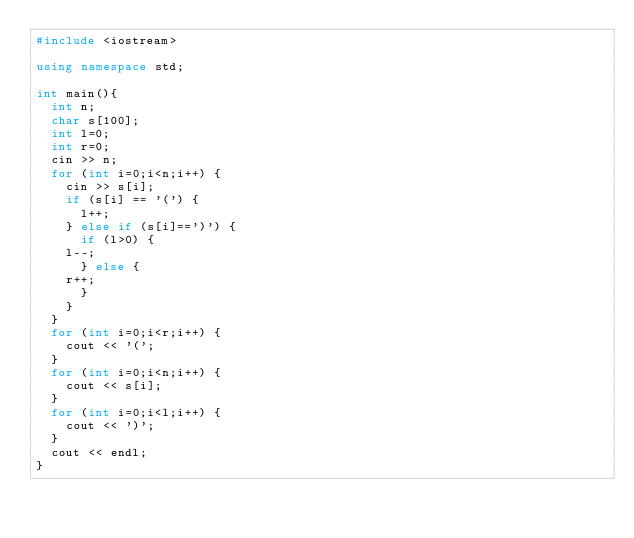<code> <loc_0><loc_0><loc_500><loc_500><_C++_>#include <iostream>

using namespace std;

int main(){
  int n;
  char s[100];
  int l=0;
  int r=0;
  cin >> n;
  for (int i=0;i<n;i++) {
    cin >> s[i];
    if (s[i] == '(') {
      l++;
    } else if (s[i]==')') {
      if (l>0) {
	l--;
      } else {
	r++;
      }
    }
  }
  for (int i=0;i<r;i++) {
    cout << '(';
  }
  for (int i=0;i<n;i++) {
    cout << s[i];
  }
  for (int i=0;i<l;i++) {
    cout << ')';
  }
  cout << endl;
}

</code> 